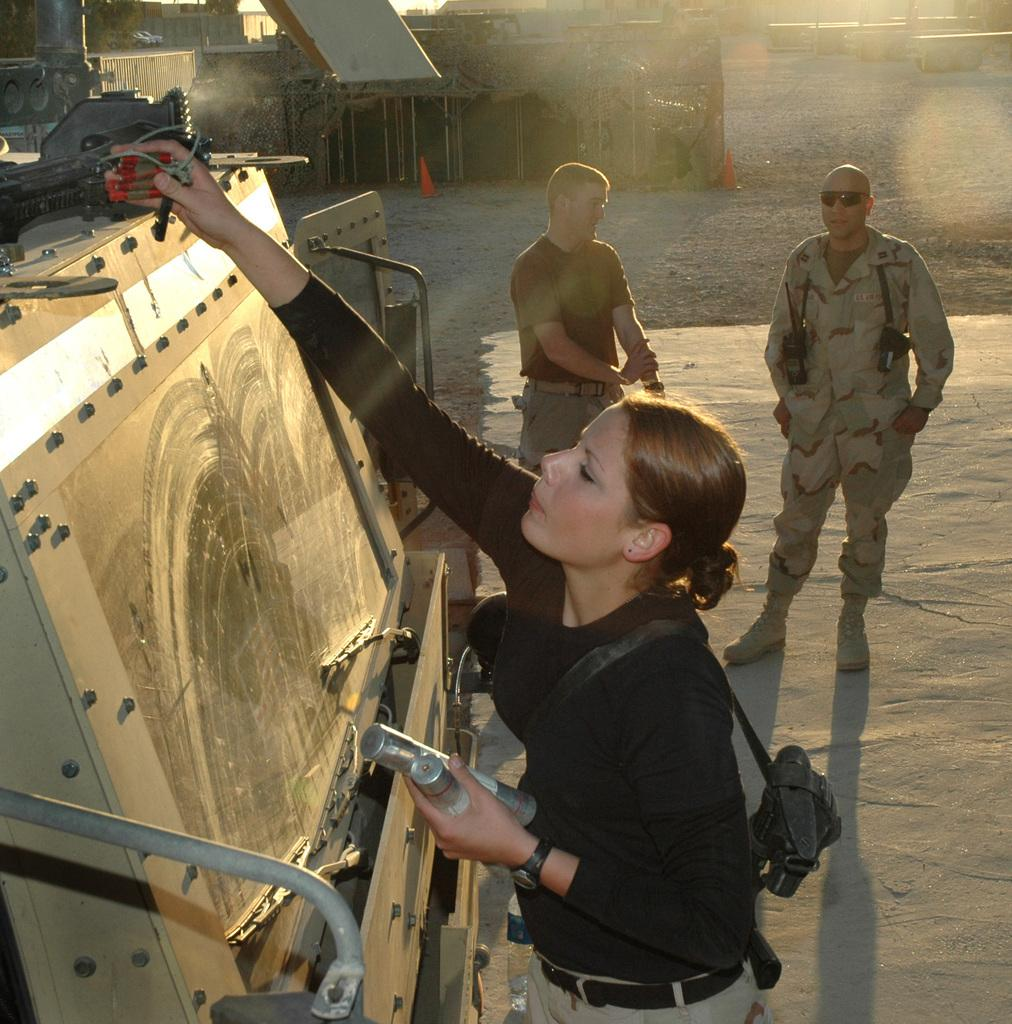How many people are in the front of the image? There are three people in the front of the image. Can you describe one of the people in the image? One of the people is a woman. What is the woman wearing in the image? The woman is wearing a bag and a black color shirt. What can be seen in the background of the image? There are buildings in the background of the image. How many potatoes can be seen in the image? There are no potatoes present in the image. Is there a rainstorm happening in the image? There is no indication of a rainstorm in the image; the sky appears clear. 